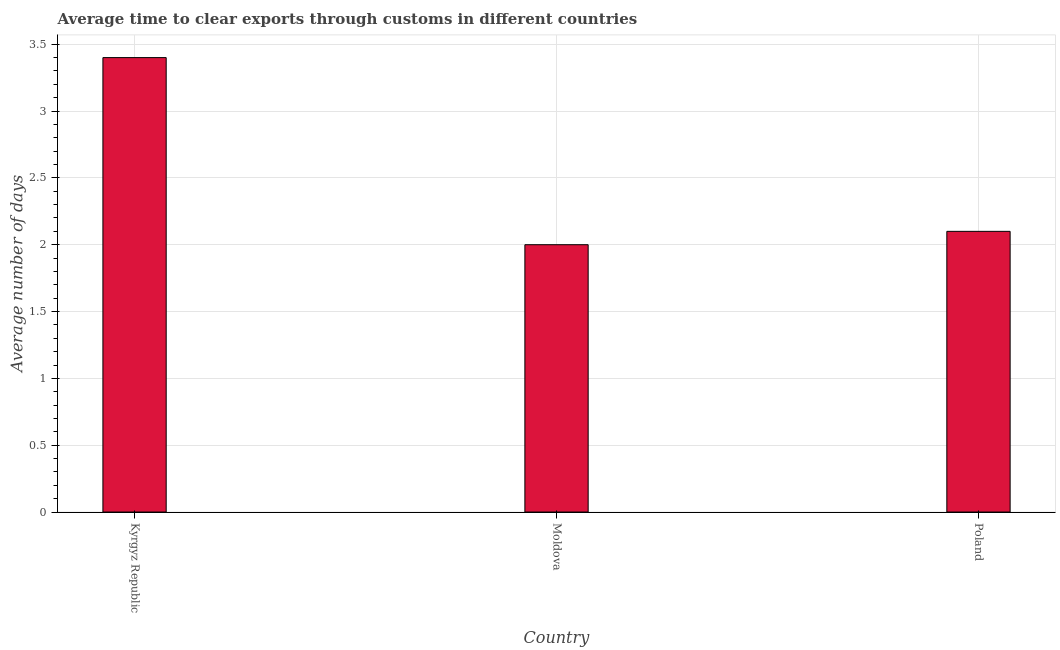Does the graph contain any zero values?
Offer a terse response. No. Does the graph contain grids?
Your answer should be very brief. Yes. What is the title of the graph?
Your answer should be compact. Average time to clear exports through customs in different countries. What is the label or title of the Y-axis?
Provide a short and direct response. Average number of days. In which country was the time to clear exports through customs maximum?
Offer a very short reply. Kyrgyz Republic. In which country was the time to clear exports through customs minimum?
Keep it short and to the point. Moldova. What is the sum of the time to clear exports through customs?
Give a very brief answer. 7.5. What is the average time to clear exports through customs per country?
Your answer should be very brief. 2.5. What is the median time to clear exports through customs?
Keep it short and to the point. 2.1. In how many countries, is the time to clear exports through customs greater than 3.2 days?
Provide a short and direct response. 1. What is the ratio of the time to clear exports through customs in Kyrgyz Republic to that in Poland?
Provide a short and direct response. 1.62. What is the difference between the highest and the second highest time to clear exports through customs?
Your answer should be very brief. 1.3. In how many countries, is the time to clear exports through customs greater than the average time to clear exports through customs taken over all countries?
Ensure brevity in your answer.  1. Are all the bars in the graph horizontal?
Give a very brief answer. No. How many countries are there in the graph?
Your answer should be compact. 3. What is the difference between two consecutive major ticks on the Y-axis?
Your answer should be very brief. 0.5. What is the Average number of days in Moldova?
Ensure brevity in your answer.  2. What is the difference between the Average number of days in Kyrgyz Republic and Poland?
Make the answer very short. 1.3. What is the difference between the Average number of days in Moldova and Poland?
Give a very brief answer. -0.1. What is the ratio of the Average number of days in Kyrgyz Republic to that in Poland?
Keep it short and to the point. 1.62. 